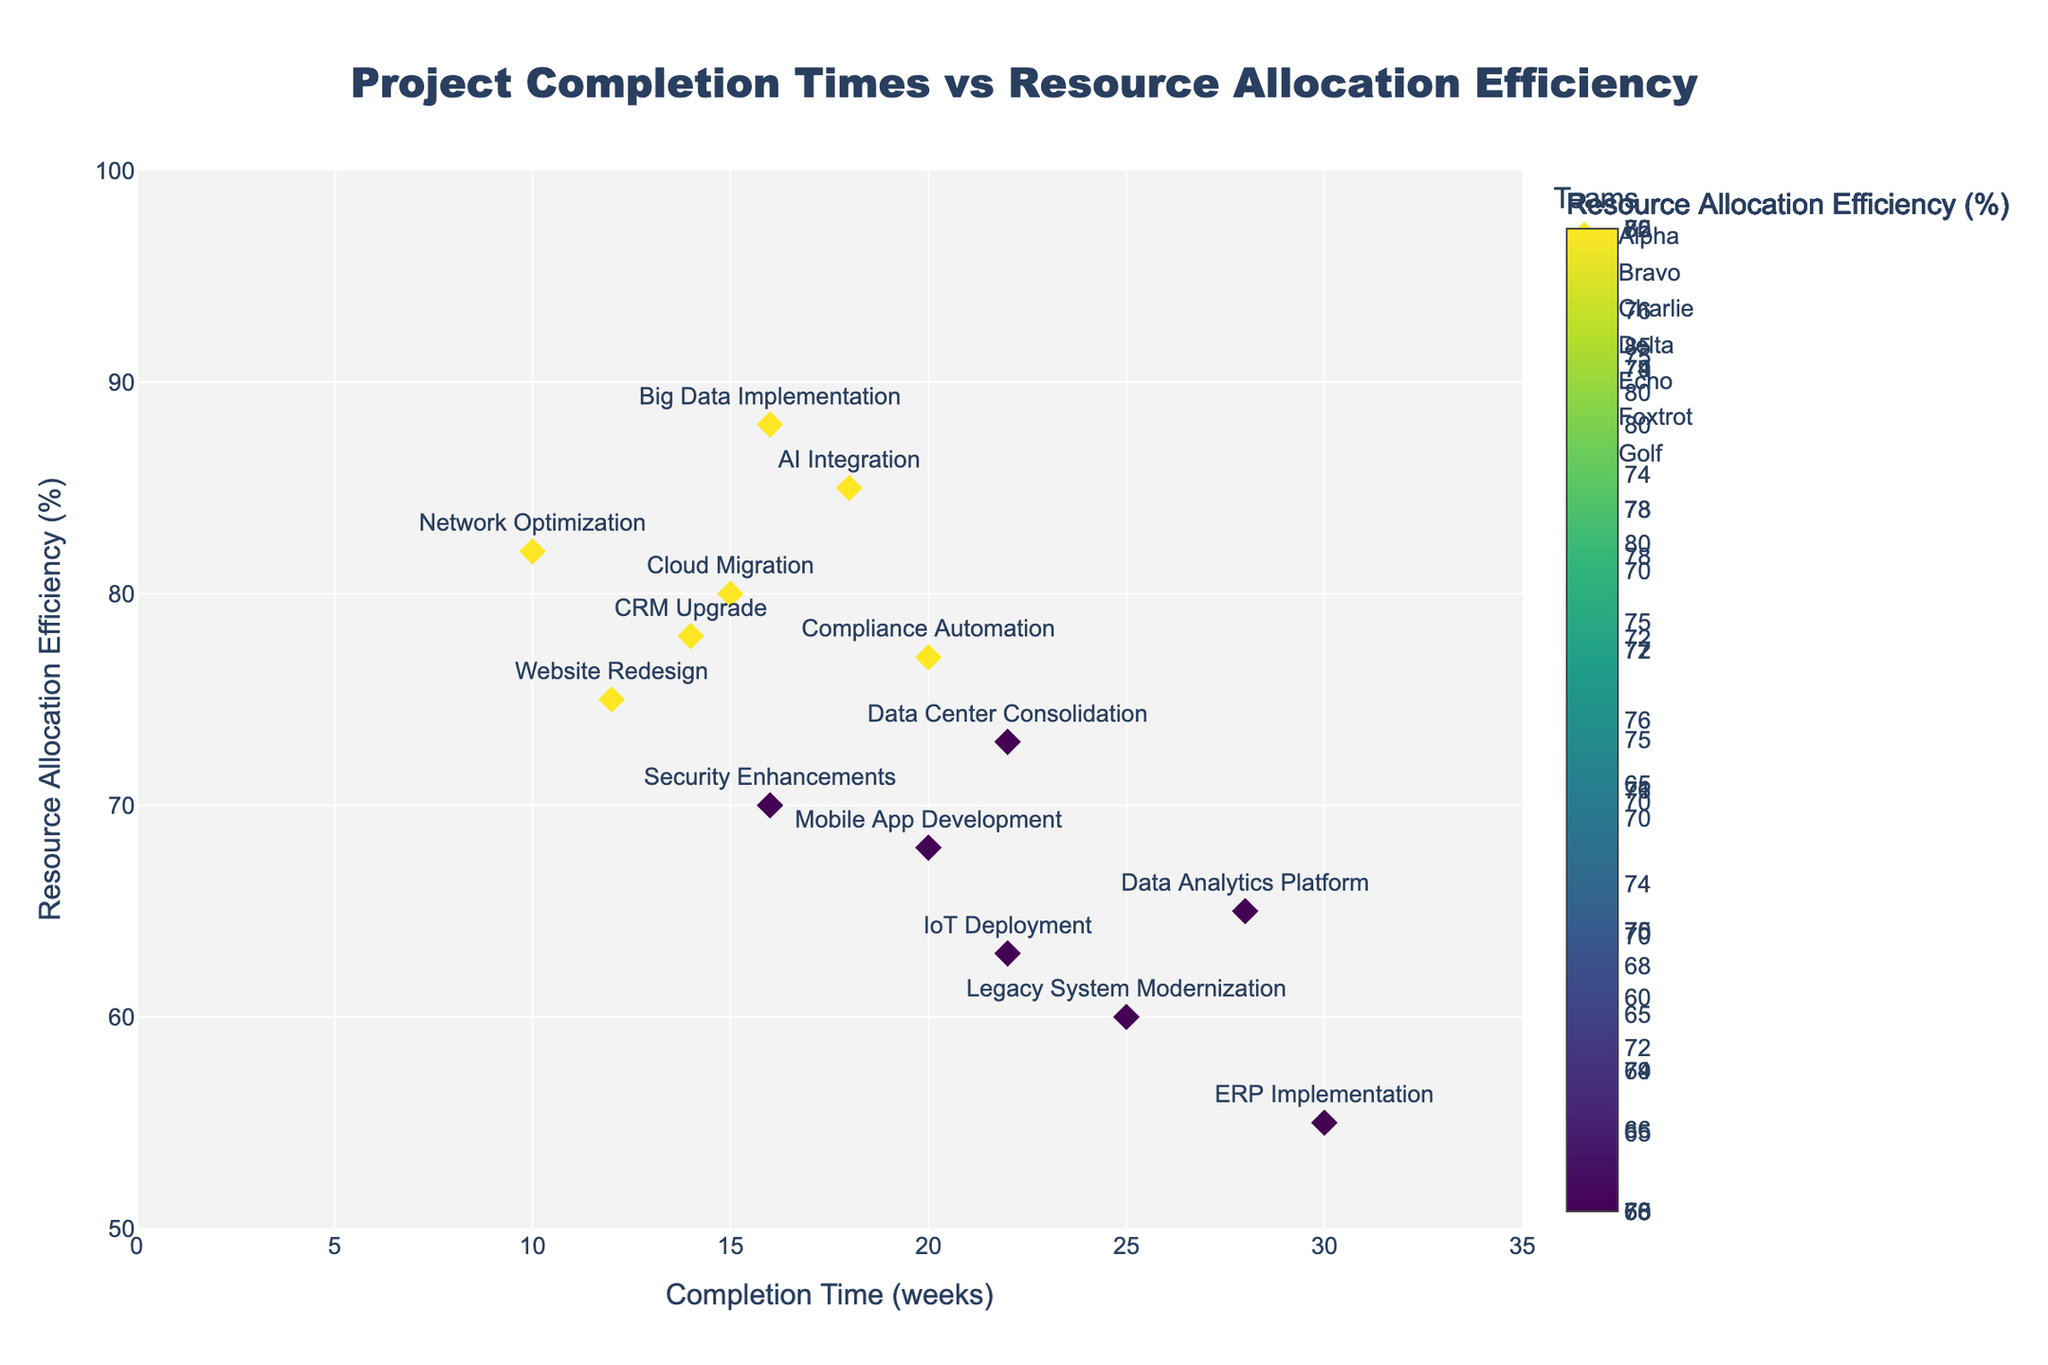How many different teams are represented in the plot? Count the unique team names in the legend
Answer: 7 What are the title and axis labels of the plot? Read the text in the title and axis labels on the figure
Answer: Title: Project Completion Times vs Resource Allocation Efficiency; X-axis: Completion Time (weeks); Y-axis: Resource Allocation Efficiency (%) Which team has the shortest project completion time? Find the team with the minimum x-coordinate (Completion Time) from the plot
Answer: Echo Which project has the highest resource allocation efficiency? Identify the project at the highest y-coordinate (Resource Allocation Efficiency) in the plot
Answer: Big Data Implementation (Golf Team) What is the range of completion times displayed in the plot? Find the smallest and largest values on the x-axis
Answer: 10 to 30 weeks Which team has the most consistently high resource allocation efficiency? Look for the team whose points are highest and closest to each other on the y-axis
Answer: Charlie Which team has the least efficient project in terms of resource allocation? Find the team with the project at the lowest y-coordinate
Answer: Delta (ERP Implementation, 55%) Compare the resource allocation efficiencies between the teams Echo and Bravo. Which one is higher on average? Identify and average the y-coordinates for Echo and Bravo, then compare
Answer: Bravo (80 and 73) has higher average efficiency (76.5%) compared to Echo (82 and 70) with an average of 76% What is the difference in completion times between the fastest project of team Alpha and the slowest project of team Delta? Determine the minimum completion time for Alpha and the maximum for Delta, then calculate the difference
Answer: Fastest for Alpha: 12 weeks; Slowest for Delta: 30 weeks; Difference = 30 - 12 = 18 weeks How does the resource allocation efficiency correlate with completion time? Observe the general trend of data points on the plot
Answer: Negative correlation (higher efficiency often associates with shorter completion times) 